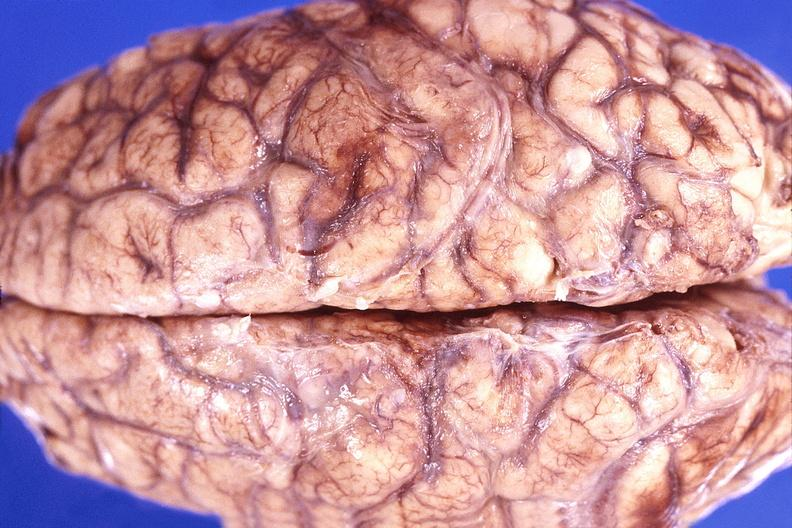what is present?
Answer the question using a single word or phrase. Nervous 